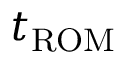<formula> <loc_0><loc_0><loc_500><loc_500>t _ { R O M }</formula> 